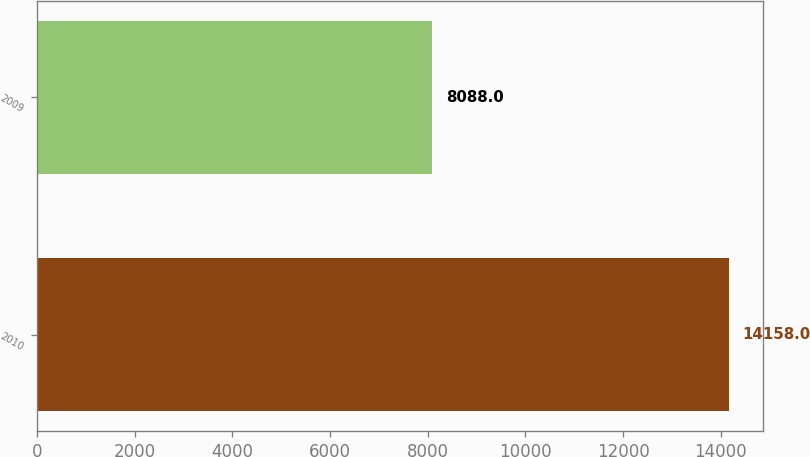<chart> <loc_0><loc_0><loc_500><loc_500><bar_chart><fcel>2010<fcel>2009<nl><fcel>14158<fcel>8088<nl></chart> 